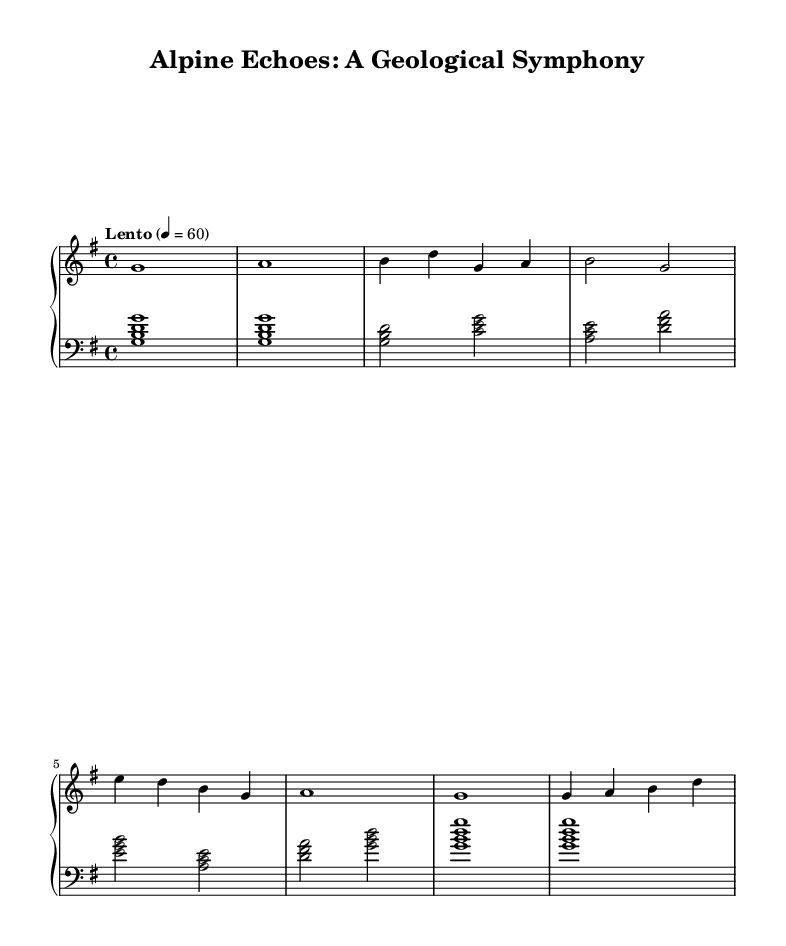What is the key signature of this music? The key signature features one sharp, indicating it is in G major.
Answer: G major What is the time signature of this music? The time signature is indicated by the fraction at the beginning of the score, which shows there are four beats in each measure.
Answer: 4/4 What is the tempo marking for this piece? The tempo marking is provided in words, indicating the speed of the piece is "Lento," which means slow.
Answer: Lento How many sections are present in the music? The music is divided into three distinct sections: an intro, an A section, and a B section, followed by an outro.
Answer: Four What are the first notes of the right hand in the intro? The intro begins with the notes written out for the right hand, starting with a G note followed by an A note.
Answer: G, A What chord is played in the left hand at the beginning? The left hand starts with a G major chord, which consists of the notes G, B, and D.
Answer: G major In which section does the note E appear? The note E appears during the B section of the composition, as indicated by its location in the sequence.
Answer: B section 